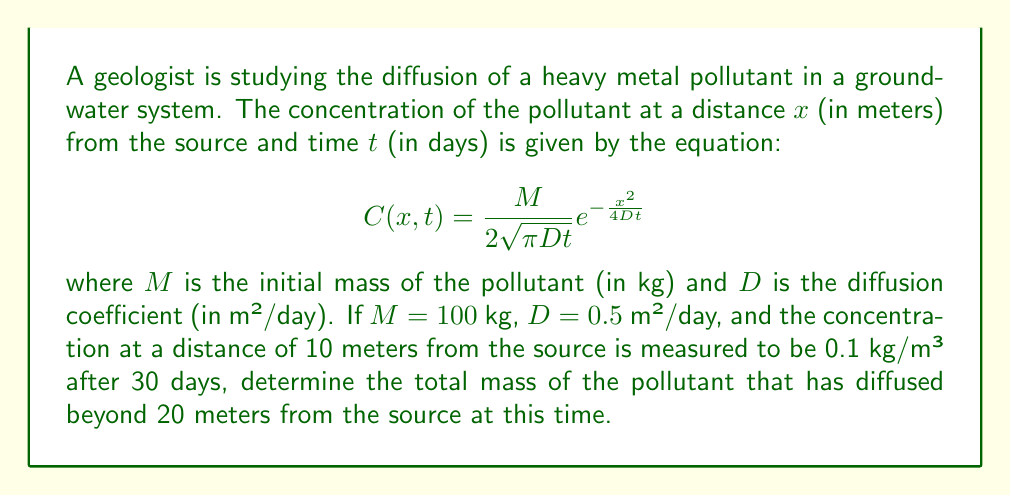Can you solve this math problem? To solve this problem, we'll follow these steps:

1) First, we need to verify the given concentration at 10 meters after 30 days:

   $$C(10,30) = \frac{100}{2\sqrt{\pi \cdot 0.5 \cdot 30}} e^{-\frac{10^2}{4 \cdot 0.5 \cdot 30}} \approx 0.1 \text{ kg/m³}$$

   This confirms the given information.

2) To find the total mass beyond 20 meters, we need to integrate the concentration function from 20 to infinity:

   $$M_{>20} = \int_{20}^{\infty} C(x,30) \cdot 1 \text{ m²} \, dx$$

   The 1 m² factor is to convert from linear concentration to mass per unit width.

3) Substituting the concentration function:

   $$M_{>20} = \int_{20}^{\infty} \frac{100}{2\sqrt{\pi \cdot 0.5 \cdot 30}} e^{-\frac{x^2}{4 \cdot 0.5 \cdot 30}} \cdot 1 \text{ m²} \, dx$$

4) This integral can be solved using the complementary error function (erfc):

   $$M_{>20} = 100 \cdot \frac{1}{2} \text{erfc}\left(\frac{20}{2\sqrt{0.5 \cdot 30}}\right) \text{ kg}$$

5) Evaluating this:

   $$M_{>20} = 100 \cdot \frac{1}{2} \text{erfc}(2.58) \approx 0.49 \text{ kg}$$

Therefore, approximately 0.49 kg of the pollutant has diffused beyond 20 meters from the source after 30 days.
Answer: 0.49 kg 